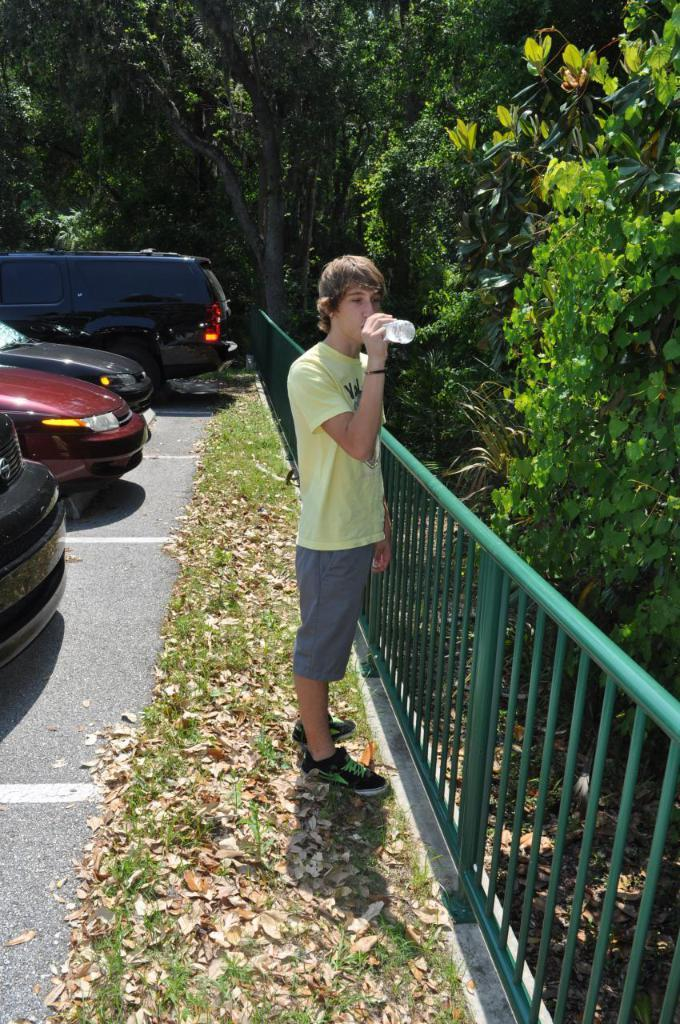What is the man in the image doing? The man is standing in the image and holding a bottle. What else can be seen in the image besides the man? There are vehicles on the road and iron grilles in the image. What is visible in the background of the image? There are trees in the background of the image. What is the relation between the man and the authority in the image? There is no mention of an authority figure in the image, so it is not possible to determine the relation between the man and any authority. 